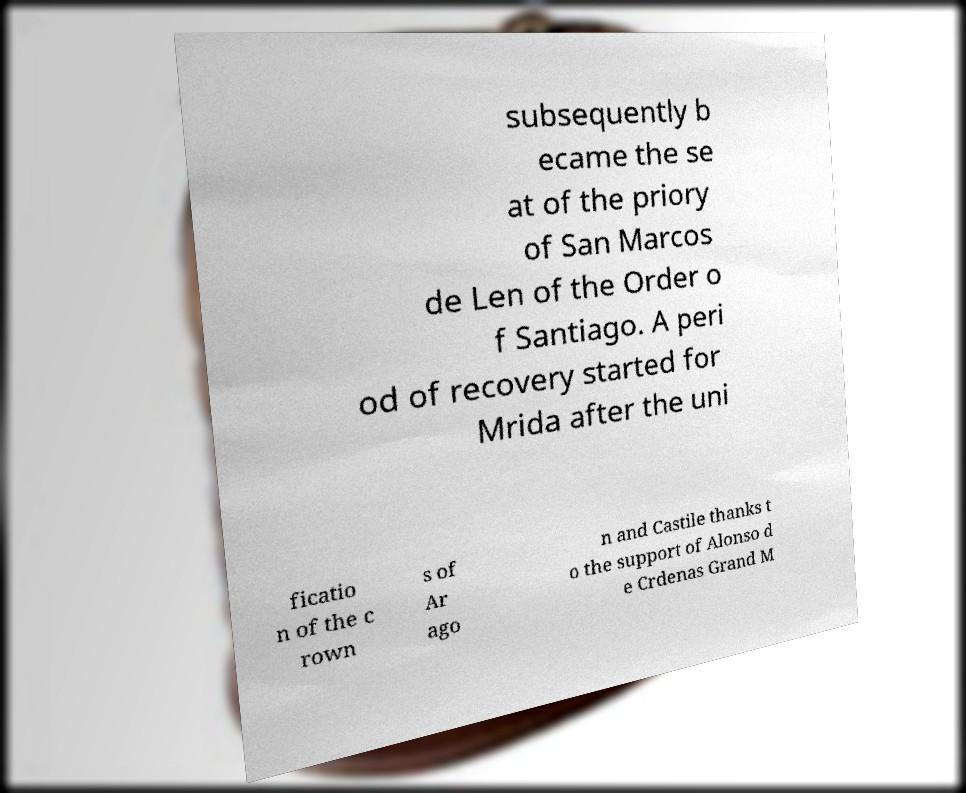Could you extract and type out the text from this image? subsequently b ecame the se at of the priory of San Marcos de Len of the Order o f Santiago. A peri od of recovery started for Mrida after the uni ficatio n of the c rown s of Ar ago n and Castile thanks t o the support of Alonso d e Crdenas Grand M 